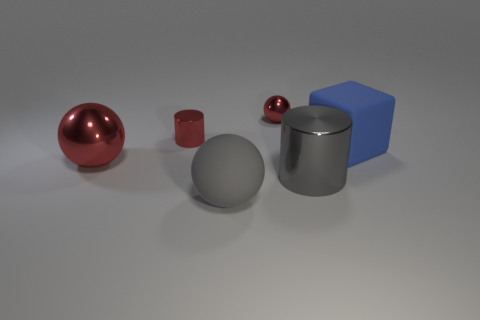Add 2 small shiny cylinders. How many objects exist? 8 Subtract all cubes. How many objects are left? 5 Add 5 blue cubes. How many blue cubes are left? 6 Add 4 tiny yellow metal spheres. How many tiny yellow metal spheres exist? 4 Subtract 0 brown spheres. How many objects are left? 6 Subtract all purple things. Subtract all big red shiny spheres. How many objects are left? 5 